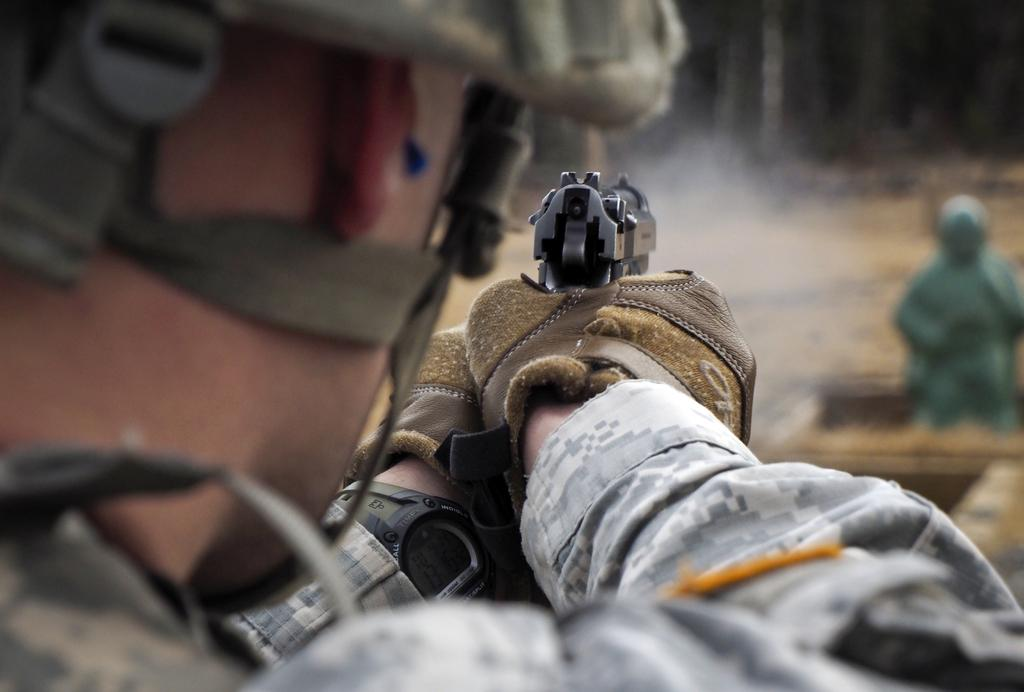What is the main subject of the image? There is a man in the image. What is the man doing in the image? The man is standing in the image. What object is the man holding in the image? The man is holding a gun in the image. Can you describe the background of the image? The background of the image is blurred. What type of twig is the man using to light the match in the image? There is no twig or match present in the image; the man is holding a gun. 